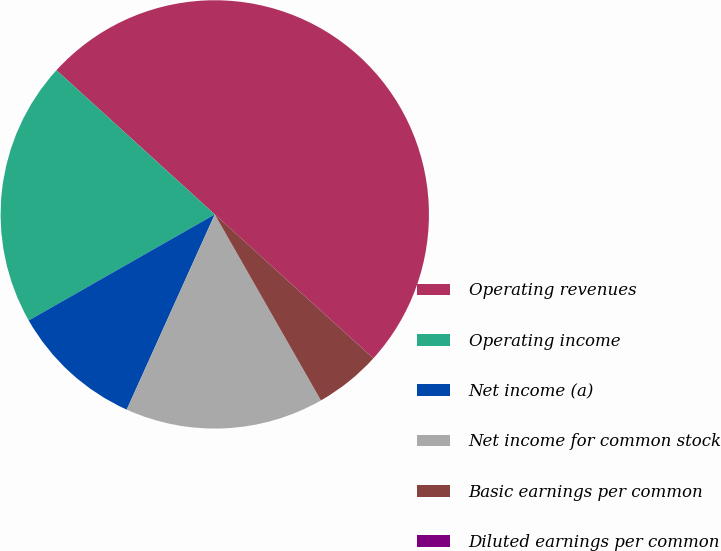Convert chart. <chart><loc_0><loc_0><loc_500><loc_500><pie_chart><fcel>Operating revenues<fcel>Operating income<fcel>Net income (a)<fcel>Net income for common stock<fcel>Basic earnings per common<fcel>Diluted earnings per common<nl><fcel>49.97%<fcel>20.0%<fcel>10.01%<fcel>15.0%<fcel>5.01%<fcel>0.01%<nl></chart> 